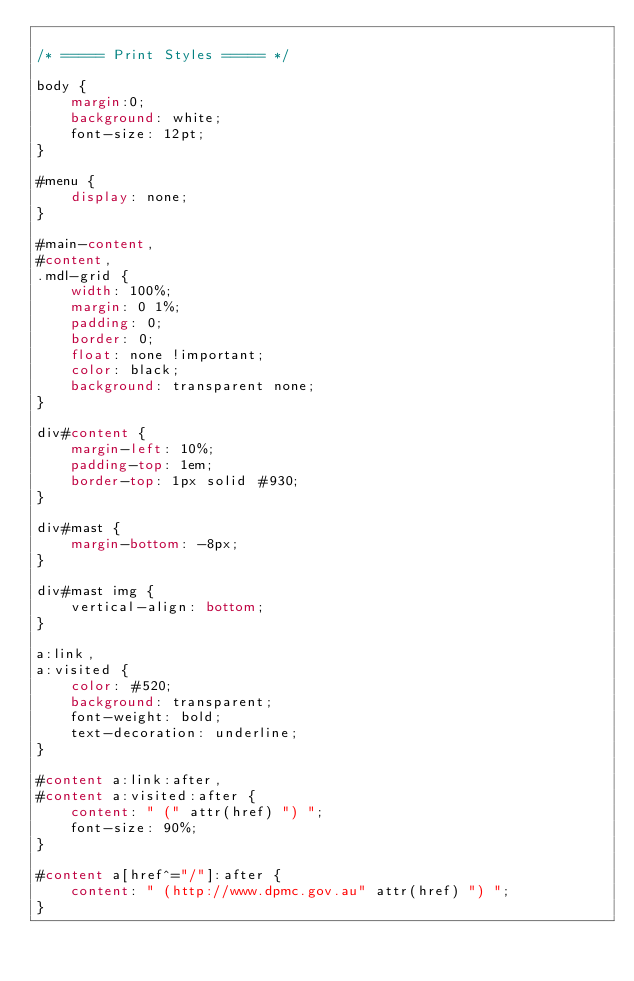<code> <loc_0><loc_0><loc_500><loc_500><_CSS_>
/* ===== Print Styles ===== */

body { 
    margin:0;
	background: white; 
	font-size: 12pt; 
}
	
#menu { 
	display: none; 
}
	
#main-content, 
#content,
.mdl-grid { 
	width: 100%; 
	margin: 0 1%; 
	padding: 0; 
	border: 0; 
	float: none !important; 
	color: black; 
	background: transparent none; 
}
	
div#content { 
	margin-left: 10%; 
	padding-top: 1em; 
	border-top: 1px solid #930; 
}
	
div#mast { 
	margin-bottom: -8px; 
}
	
div#mast img { 
	vertical-align: bottom; 
}
	
a:link, 
a:visited { 
	color: #520; 
	background: transparent; 
	font-weight: bold; 
	text-decoration: underline; 
}
	
#content a:link:after, 
#content a:visited:after { 
	content: " (" attr(href) ") "; 
	font-size: 90%; 
}
	
#content a[href^="/"]:after { 
	content: " (http://www.dpmc.gov.au" attr(href) ") "; 
}
</code> 